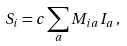<formula> <loc_0><loc_0><loc_500><loc_500>S _ { i } = c \sum _ { a } M _ { i a } I _ { a } \, ,</formula> 